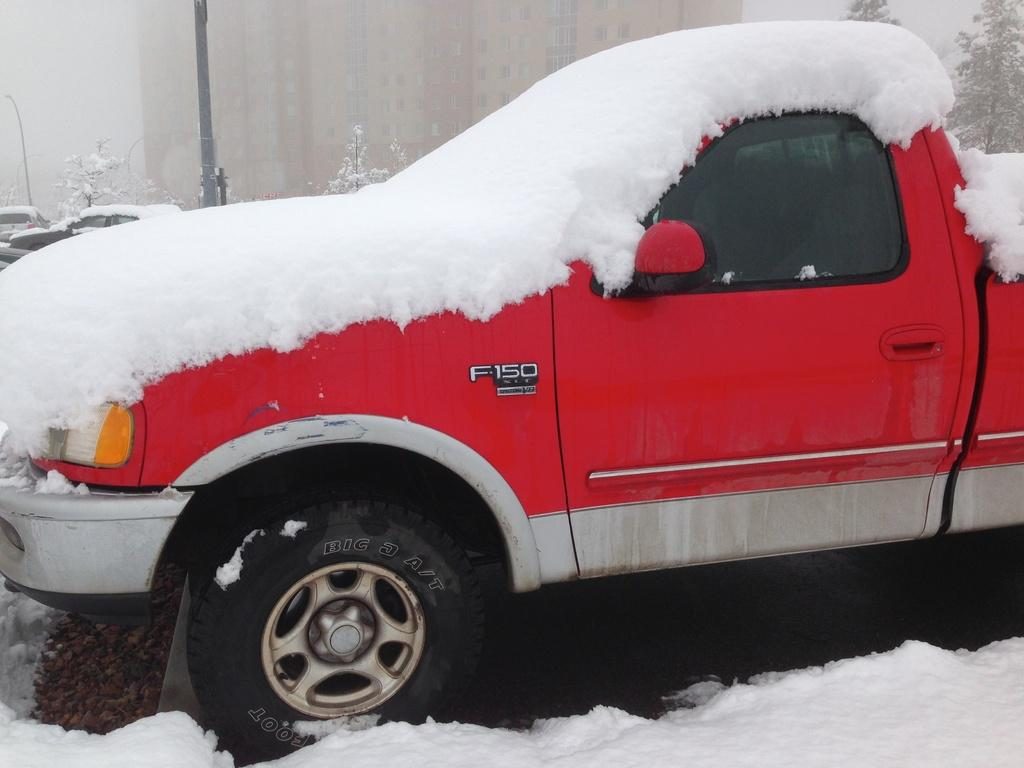<image>
Describe the image concisely. A red Ford F 150 that is covered in snow. 